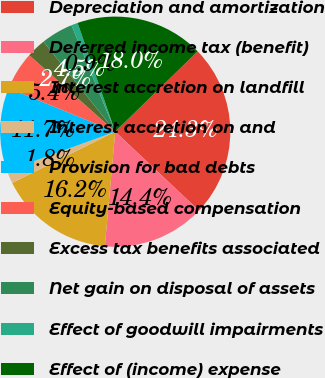Convert chart. <chart><loc_0><loc_0><loc_500><loc_500><pie_chart><fcel>Depreciation and amortization<fcel>Deferred income tax (benefit)<fcel>Interest accretion on landfill<fcel>Interest accretion on and<fcel>Provision for bad debts<fcel>Equity-based compensation<fcel>Excess tax benefits associated<fcel>Net gain on disposal of assets<fcel>Effect of goodwill impairments<fcel>Effect of (income) expense<nl><fcel>24.32%<fcel>14.41%<fcel>16.21%<fcel>1.81%<fcel>11.71%<fcel>5.41%<fcel>2.71%<fcel>4.51%<fcel>0.9%<fcel>18.01%<nl></chart> 